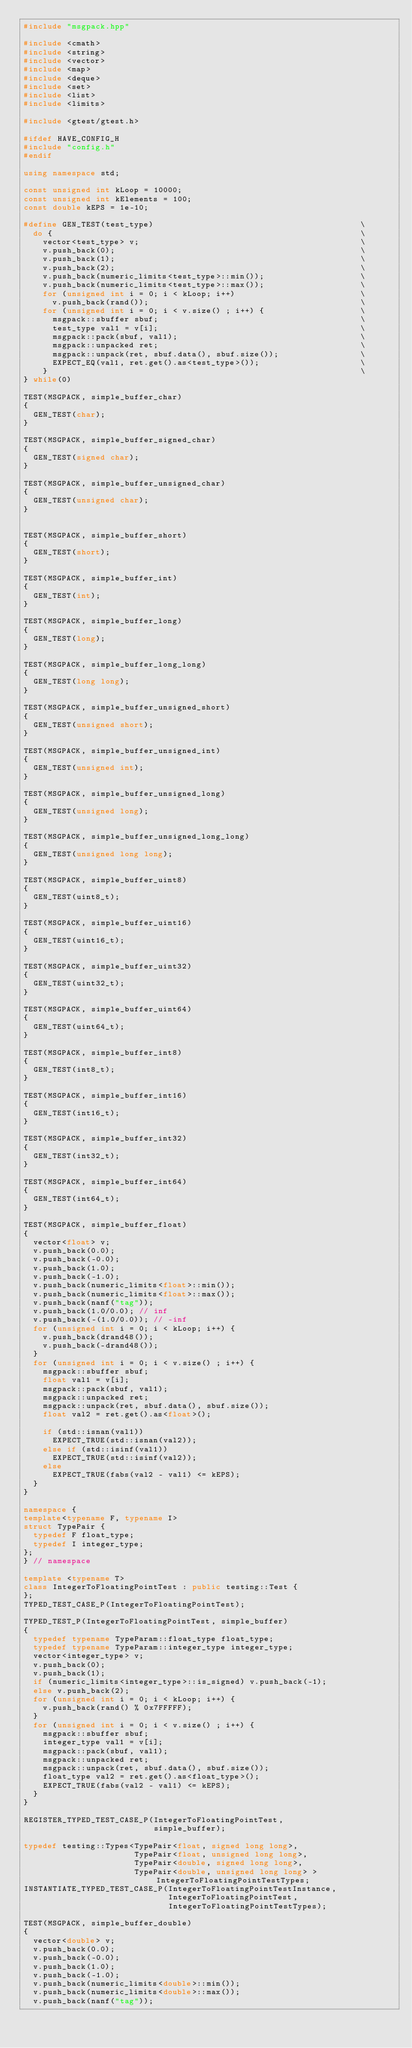<code> <loc_0><loc_0><loc_500><loc_500><_C++_>#include "msgpack.hpp"

#include <cmath>
#include <string>
#include <vector>
#include <map>
#include <deque>
#include <set>
#include <list>
#include <limits>

#include <gtest/gtest.h>

#ifdef HAVE_CONFIG_H
#include "config.h"
#endif

using namespace std;

const unsigned int kLoop = 10000;
const unsigned int kElements = 100;
const double kEPS = 1e-10;

#define GEN_TEST(test_type)                                           \
  do {                                                                \
    vector<test_type> v;                                              \
    v.push_back(0);                                                   \
    v.push_back(1);                                                   \
    v.push_back(2);                                                   \
    v.push_back(numeric_limits<test_type>::min());                    \
    v.push_back(numeric_limits<test_type>::max());                    \
    for (unsigned int i = 0; i < kLoop; i++)                          \
      v.push_back(rand());                                            \
    for (unsigned int i = 0; i < v.size() ; i++) {                    \
      msgpack::sbuffer sbuf;                                          \
      test_type val1 = v[i];                                          \
      msgpack::pack(sbuf, val1);                                      \
      msgpack::unpacked ret;                                          \
      msgpack::unpack(ret, sbuf.data(), sbuf.size());                 \
      EXPECT_EQ(val1, ret.get().as<test_type>());                     \
    }                                                                 \
} while(0)

TEST(MSGPACK, simple_buffer_char)
{
  GEN_TEST(char);
}

TEST(MSGPACK, simple_buffer_signed_char)
{
  GEN_TEST(signed char);
}

TEST(MSGPACK, simple_buffer_unsigned_char)
{
  GEN_TEST(unsigned char);
}


TEST(MSGPACK, simple_buffer_short)
{
  GEN_TEST(short);
}

TEST(MSGPACK, simple_buffer_int)
{
  GEN_TEST(int);
}

TEST(MSGPACK, simple_buffer_long)
{
  GEN_TEST(long);
}

TEST(MSGPACK, simple_buffer_long_long)
{
  GEN_TEST(long long);
}

TEST(MSGPACK, simple_buffer_unsigned_short)
{
  GEN_TEST(unsigned short);
}

TEST(MSGPACK, simple_buffer_unsigned_int)
{
  GEN_TEST(unsigned int);
}

TEST(MSGPACK, simple_buffer_unsigned_long)
{
  GEN_TEST(unsigned long);
}

TEST(MSGPACK, simple_buffer_unsigned_long_long)
{
  GEN_TEST(unsigned long long);
}

TEST(MSGPACK, simple_buffer_uint8)
{
  GEN_TEST(uint8_t);
}

TEST(MSGPACK, simple_buffer_uint16)
{
  GEN_TEST(uint16_t);
}

TEST(MSGPACK, simple_buffer_uint32)
{
  GEN_TEST(uint32_t);
}

TEST(MSGPACK, simple_buffer_uint64)
{
  GEN_TEST(uint64_t);
}

TEST(MSGPACK, simple_buffer_int8)
{
  GEN_TEST(int8_t);
}

TEST(MSGPACK, simple_buffer_int16)
{
  GEN_TEST(int16_t);
}

TEST(MSGPACK, simple_buffer_int32)
{
  GEN_TEST(int32_t);
}

TEST(MSGPACK, simple_buffer_int64)
{
  GEN_TEST(int64_t);
}

TEST(MSGPACK, simple_buffer_float)
{
  vector<float> v;
  v.push_back(0.0);
  v.push_back(-0.0);
  v.push_back(1.0);
  v.push_back(-1.0);
  v.push_back(numeric_limits<float>::min());
  v.push_back(numeric_limits<float>::max());
  v.push_back(nanf("tag"));
  v.push_back(1.0/0.0); // inf
  v.push_back(-(1.0/0.0)); // -inf
  for (unsigned int i = 0; i < kLoop; i++) {
    v.push_back(drand48());
    v.push_back(-drand48());
  }
  for (unsigned int i = 0; i < v.size() ; i++) {
    msgpack::sbuffer sbuf;
    float val1 = v[i];
    msgpack::pack(sbuf, val1);
    msgpack::unpacked ret;
    msgpack::unpack(ret, sbuf.data(), sbuf.size());
    float val2 = ret.get().as<float>();

    if (std::isnan(val1))
      EXPECT_TRUE(std::isnan(val2));
    else if (std::isinf(val1))
      EXPECT_TRUE(std::isinf(val2));
    else
      EXPECT_TRUE(fabs(val2 - val1) <= kEPS);
  }
}

namespace {
template<typename F, typename I>
struct TypePair {
  typedef F float_type;
  typedef I integer_type;
};
} // namespace

template <typename T>
class IntegerToFloatingPointTest : public testing::Test {
};
TYPED_TEST_CASE_P(IntegerToFloatingPointTest);

TYPED_TEST_P(IntegerToFloatingPointTest, simple_buffer)
{
  typedef typename TypeParam::float_type float_type;
  typedef typename TypeParam::integer_type integer_type;
  vector<integer_type> v;
  v.push_back(0);
  v.push_back(1);
  if (numeric_limits<integer_type>::is_signed) v.push_back(-1);
  else v.push_back(2);
  for (unsigned int i = 0; i < kLoop; i++) {
    v.push_back(rand() % 0x7FFFFF);
  }
  for (unsigned int i = 0; i < v.size() ; i++) {
    msgpack::sbuffer sbuf;
    integer_type val1 = v[i];
    msgpack::pack(sbuf, val1);
    msgpack::unpacked ret;
    msgpack::unpack(ret, sbuf.data(), sbuf.size());
    float_type val2 = ret.get().as<float_type>();
    EXPECT_TRUE(fabs(val2 - val1) <= kEPS);
  }
}

REGISTER_TYPED_TEST_CASE_P(IntegerToFloatingPointTest,
                           simple_buffer);

typedef testing::Types<TypePair<float, signed long long>,
                       TypePair<float, unsigned long long>,
                       TypePair<double, signed long long>,
                       TypePair<double, unsigned long long> > IntegerToFloatingPointTestTypes;
INSTANTIATE_TYPED_TEST_CASE_P(IntegerToFloatingPointTestInstance,
                              IntegerToFloatingPointTest,
                              IntegerToFloatingPointTestTypes);

TEST(MSGPACK, simple_buffer_double)
{
  vector<double> v;
  v.push_back(0.0);
  v.push_back(-0.0);
  v.push_back(1.0);
  v.push_back(-1.0);
  v.push_back(numeric_limits<double>::min());
  v.push_back(numeric_limits<double>::max());
  v.push_back(nanf("tag"));</code> 